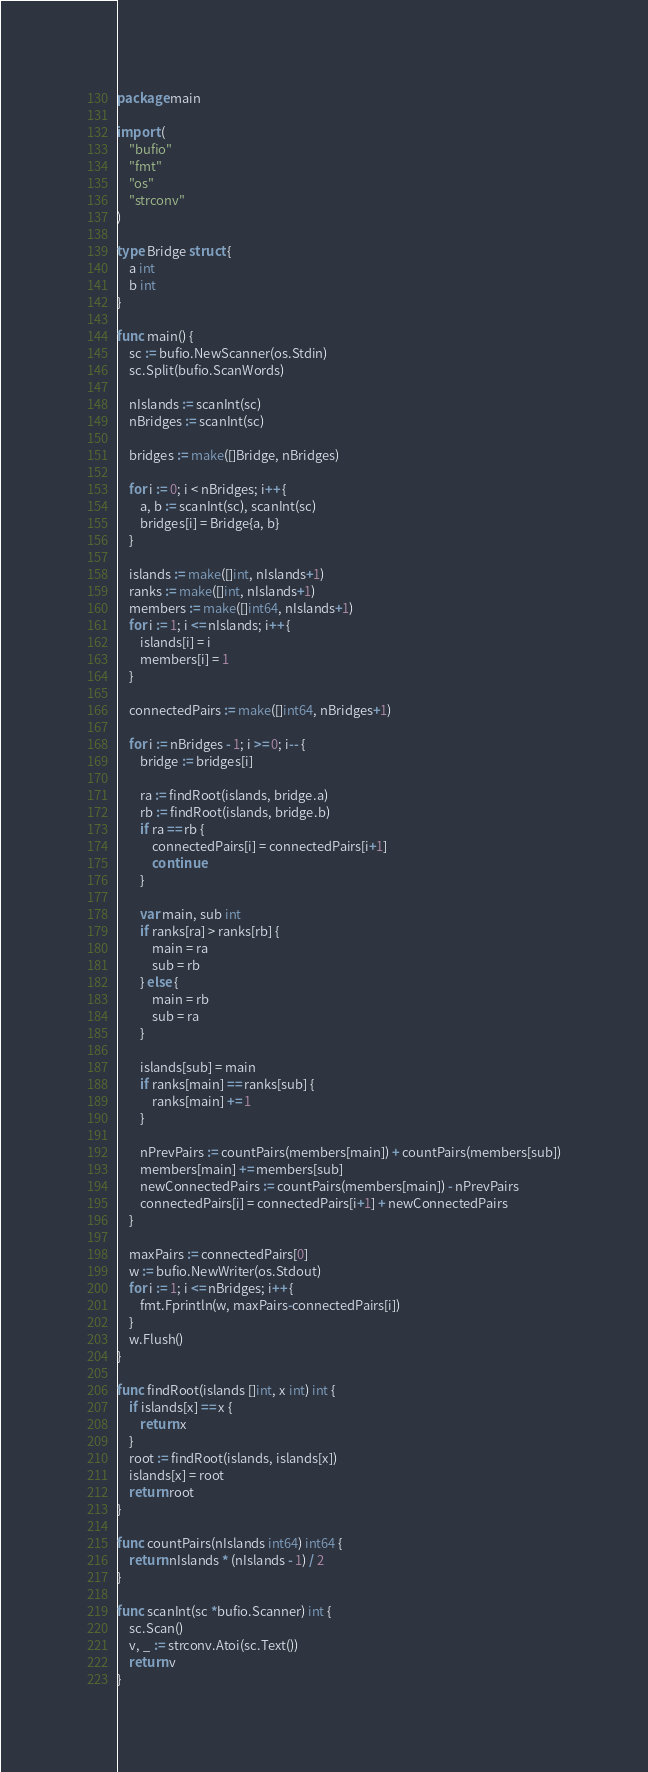Convert code to text. <code><loc_0><loc_0><loc_500><loc_500><_Go_>package main

import (
	"bufio"
	"fmt"
	"os"
	"strconv"
)

type Bridge struct {
	a int
	b int
}

func main() {
	sc := bufio.NewScanner(os.Stdin)
	sc.Split(bufio.ScanWords)

	nIslands := scanInt(sc)
	nBridges := scanInt(sc)

	bridges := make([]Bridge, nBridges)

	for i := 0; i < nBridges; i++ {
		a, b := scanInt(sc), scanInt(sc)
		bridges[i] = Bridge{a, b}
	}

	islands := make([]int, nIslands+1)
	ranks := make([]int, nIslands+1)
	members := make([]int64, nIslands+1)
	for i := 1; i <= nIslands; i++ {
		islands[i] = i
		members[i] = 1
	}

	connectedPairs := make([]int64, nBridges+1)

	for i := nBridges - 1; i >= 0; i-- {
		bridge := bridges[i]

		ra := findRoot(islands, bridge.a)
		rb := findRoot(islands, bridge.b)
		if ra == rb {
			connectedPairs[i] = connectedPairs[i+1]
			continue
		}

		var main, sub int
		if ranks[ra] > ranks[rb] {
			main = ra
			sub = rb
		} else {
			main = rb
			sub = ra
		}

		islands[sub] = main
		if ranks[main] == ranks[sub] {
			ranks[main] += 1
		}

		nPrevPairs := countPairs(members[main]) + countPairs(members[sub])
		members[main] += members[sub]
		newConnectedPairs := countPairs(members[main]) - nPrevPairs
		connectedPairs[i] = connectedPairs[i+1] + newConnectedPairs
	}

	maxPairs := connectedPairs[0]
	w := bufio.NewWriter(os.Stdout)
	for i := 1; i <= nBridges; i++ {
		fmt.Fprintln(w, maxPairs-connectedPairs[i])
	}
	w.Flush()
}

func findRoot(islands []int, x int) int {
	if islands[x] == x {
		return x
	}
	root := findRoot(islands, islands[x])
	islands[x] = root
	return root
}

func countPairs(nIslands int64) int64 {
	return nIslands * (nIslands - 1) / 2
}

func scanInt(sc *bufio.Scanner) int {
	sc.Scan()
	v, _ := strconv.Atoi(sc.Text())
	return v
}
</code> 